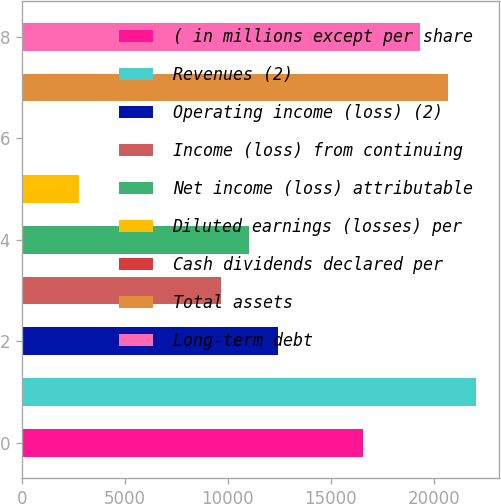<chart> <loc_0><loc_0><loc_500><loc_500><bar_chart><fcel>( in millions except per share<fcel>Revenues (2)<fcel>Operating income (loss) (2)<fcel>Income (loss) from continuing<fcel>Net income (loss) attributable<fcel>Diluted earnings (losses) per<fcel>Cash dividends declared per<fcel>Total assets<fcel>Long-term debt<nl><fcel>16555<fcel>22073.1<fcel>12416.5<fcel>9657.41<fcel>11036.9<fcel>2759.81<fcel>0.77<fcel>20693.6<fcel>19314<nl></chart> 